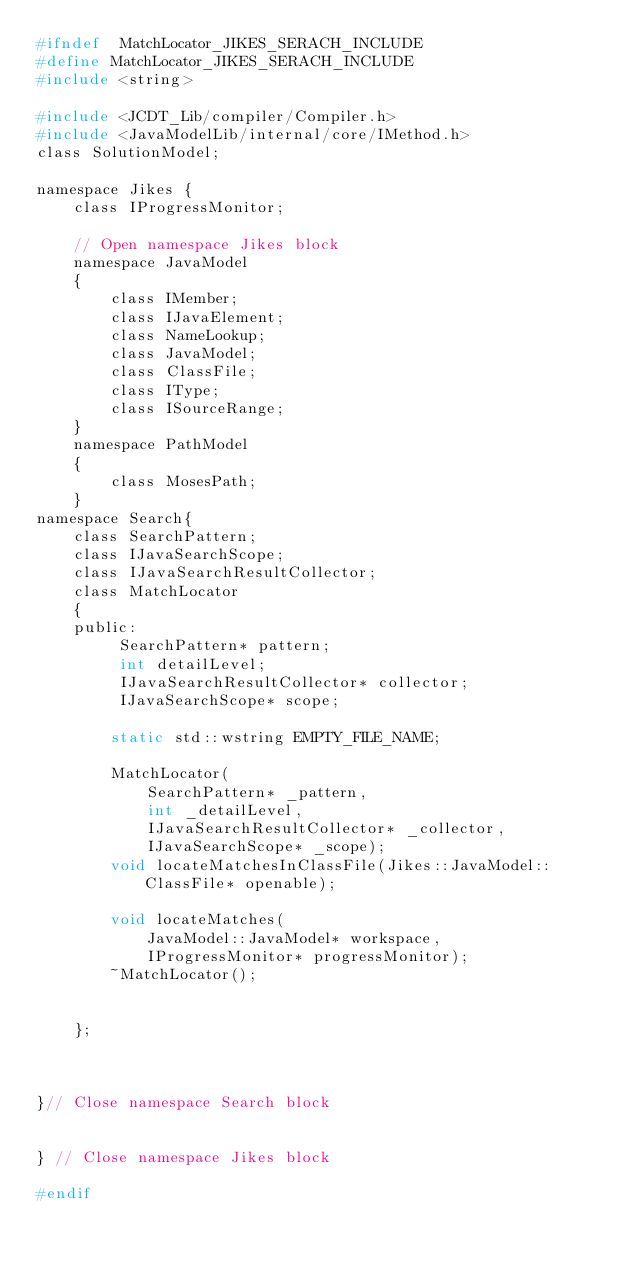<code> <loc_0><loc_0><loc_500><loc_500><_C_>#ifndef  MatchLocator_JIKES_SERACH_INCLUDE
#define MatchLocator_JIKES_SERACH_INCLUDE
#include <string>

#include <JCDT_Lib/compiler/Compiler.h>
#include <JavaModelLib/internal/core/IMethod.h>
class SolutionModel;

namespace Jikes {
	class IProgressMonitor;

	// Open namespace Jikes block
	namespace JavaModel
	{
		class IMember;
		class IJavaElement;
		class NameLookup;
		class JavaModel;
		class ClassFile;
		class IType;
		class ISourceRange;
	}
	namespace PathModel
	{
		class MosesPath;
	}
namespace Search{
	class SearchPattern;
	class IJavaSearchScope;
	class IJavaSearchResultCollector;
	class MatchLocator
	{
	public:
		 SearchPattern* pattern;
		 int detailLevel;
		 IJavaSearchResultCollector* collector;
		 IJavaSearchScope* scope;

		static std::wstring EMPTY_FILE_NAME;

		MatchLocator(
			SearchPattern* _pattern,
			int _detailLevel,
			IJavaSearchResultCollector* _collector,
			IJavaSearchScope* _scope);
		void locateMatchesInClassFile(Jikes::JavaModel::ClassFile* openable);

		void locateMatches(
			JavaModel::JavaModel* workspace,
			IProgressMonitor* progressMonitor);
		~MatchLocator();

		
	};



}// Close namespace Search block
	

} // Close namespace Jikes block

#endif</code> 